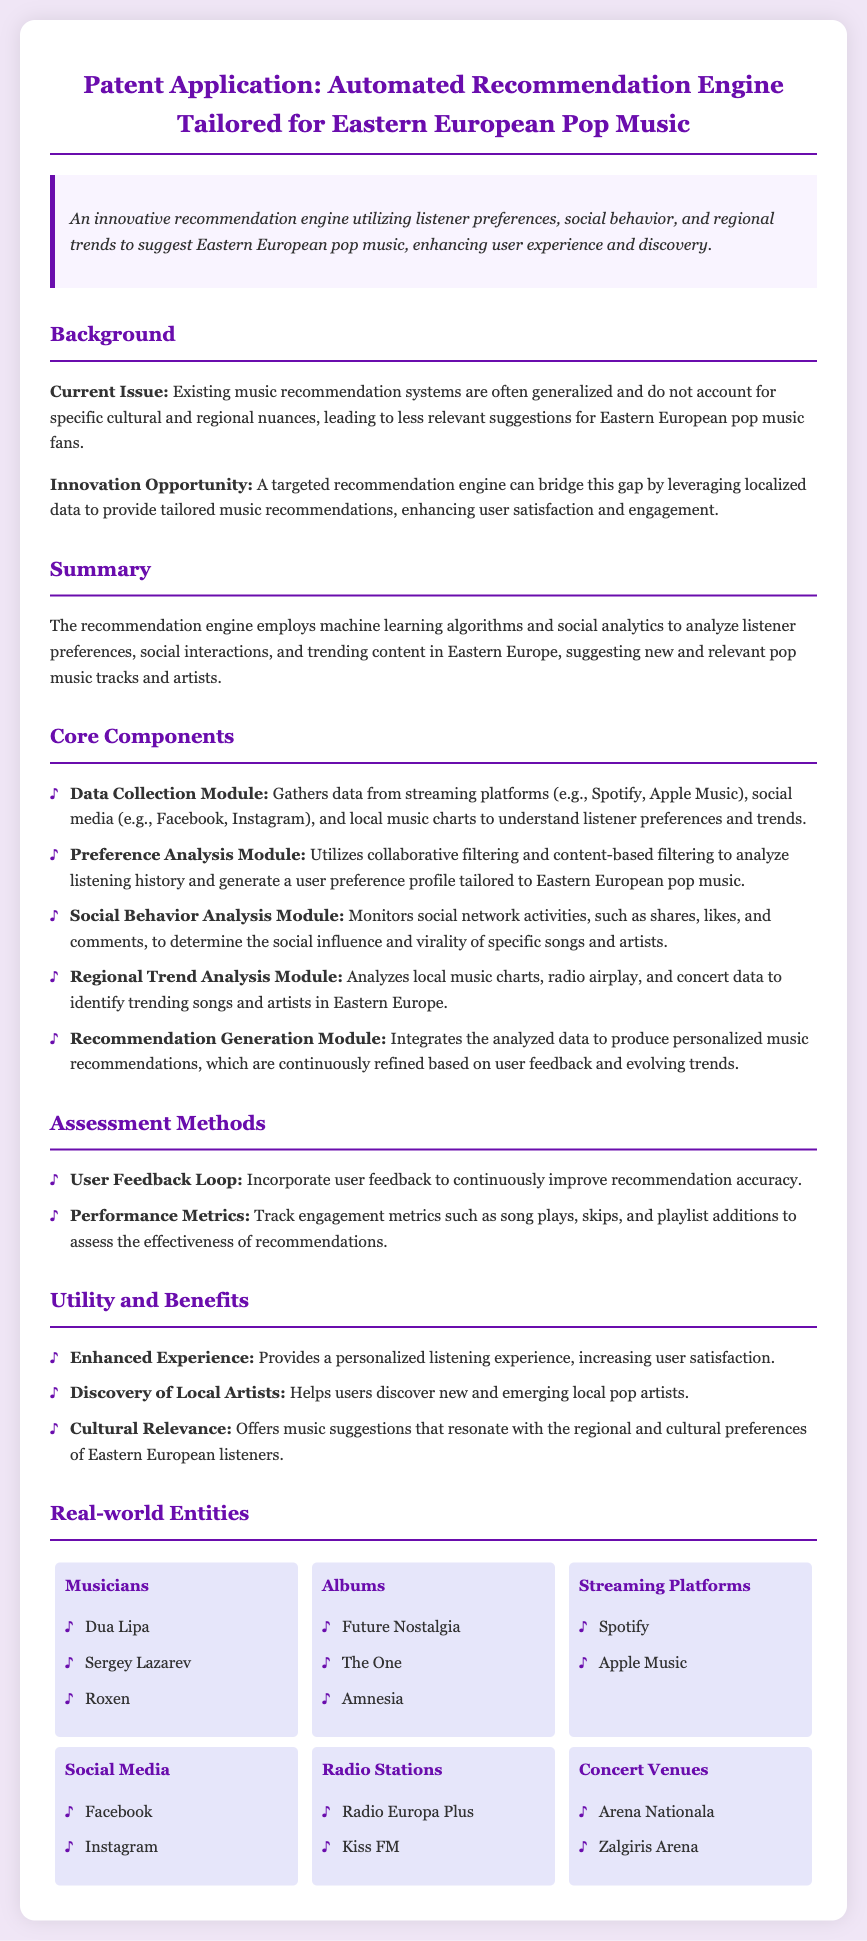What is the title of the patent application? The title of the patent application is clearly stated at the beginning and refers to the automated recommendation engine for Eastern European pop music.
Answer: Automated Recommendation Engine Tailored for Eastern European Pop Music What are the core components listed in the document? The core components are specified in a list format, detailing each module involved in the recommendation engine.
Answer: Data Collection Module, Preference Analysis Module, Social Behavior Analysis Module, Regional Trend Analysis Module, Recommendation Generation Module Which musicians are mentioned in the document? The document lists notable musicians in a specific section dedicated to real-world entities.
Answer: Dua Lipa, Sergey Lazarev, Roxen What unique advantage does this recommendation engine provide? The document emphasizes the cultural significance and user satisfaction as key benefits of the recommendation system.
Answer: Cultural Relevance What is the primary function of the Preference Analysis Module? The document specifies the role of this module in processing listener preferences for tailored recommendations.
Answer: Analyze listening history and generate a user preference profile How is user feedback utilized in the recommendation process? The document highlights the importance of user feedback in enhancing the recommendation accuracy over time.
Answer: User Feedback Loop What type of algorithms does the recommendation engine employ? The document mentions the use of specific algorithms within the summary without providing exact types.
Answer: Machine learning algorithms Where does the Data Collection Module gather data from? The document outlines various sources listed for data collection in the core components section.
Answer: Streaming platforms, social media, local music charts 